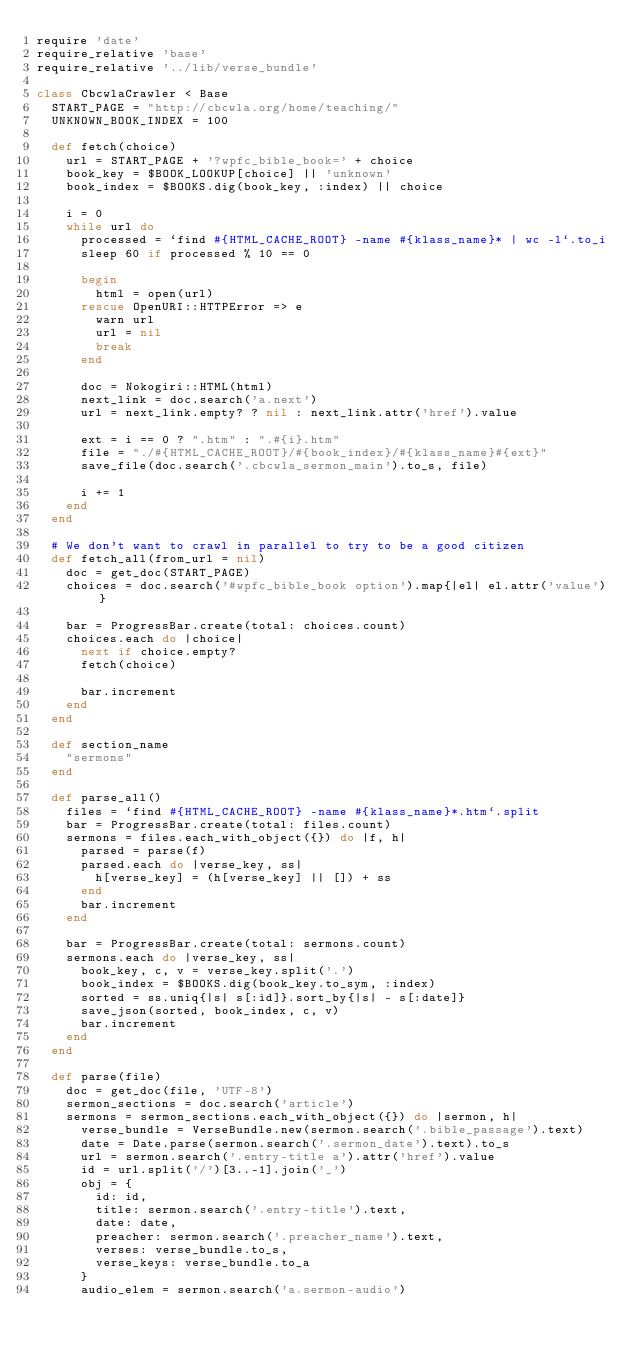Convert code to text. <code><loc_0><loc_0><loc_500><loc_500><_Ruby_>require 'date'
require_relative 'base'
require_relative '../lib/verse_bundle'

class CbcwlaCrawler < Base
  START_PAGE = "http://cbcwla.org/home/teaching/"
  UNKNOWN_BOOK_INDEX = 100

  def fetch(choice)
    url = START_PAGE + '?wpfc_bible_book=' + choice
    book_key = $BOOK_LOOKUP[choice] || 'unknown'
    book_index = $BOOKS.dig(book_key, :index) || choice

    i = 0
    while url do
      processed = `find #{HTML_CACHE_ROOT} -name #{klass_name}* | wc -l`.to_i
      sleep 60 if processed % 10 == 0

      begin
        html = open(url)
      rescue OpenURI::HTTPError => e
        warn url
        url = nil
        break
      end

      doc = Nokogiri::HTML(html)
      next_link = doc.search('a.next')
      url = next_link.empty? ? nil : next_link.attr('href').value

      ext = i == 0 ? ".htm" : ".#{i}.htm"
      file = "./#{HTML_CACHE_ROOT}/#{book_index}/#{klass_name}#{ext}"
      save_file(doc.search('.cbcwla_sermon_main').to_s, file)

      i += 1
    end
  end

  # We don't want to crawl in parallel to try to be a good citizen
  def fetch_all(from_url = nil)
    doc = get_doc(START_PAGE)
    choices = doc.search('#wpfc_bible_book option').map{|el| el.attr('value')}

    bar = ProgressBar.create(total: choices.count)
    choices.each do |choice|
      next if choice.empty?
      fetch(choice)

      bar.increment
    end
  end

  def section_name
    "sermons"
  end

  def parse_all()
    files = `find #{HTML_CACHE_ROOT} -name #{klass_name}*.htm`.split
    bar = ProgressBar.create(total: files.count)
    sermons = files.each_with_object({}) do |f, h|
      parsed = parse(f)
      parsed.each do |verse_key, ss|
        h[verse_key] = (h[verse_key] || []) + ss
      end
      bar.increment
    end

    bar = ProgressBar.create(total: sermons.count)
    sermons.each do |verse_key, ss|
      book_key, c, v = verse_key.split('.')
      book_index = $BOOKS.dig(book_key.to_sym, :index)
      sorted = ss.uniq{|s| s[:id]}.sort_by{|s| - s[:date]}
      save_json(sorted, book_index, c, v)
      bar.increment
    end
  end

  def parse(file)
    doc = get_doc(file, 'UTF-8')
    sermon_sections = doc.search('article')
    sermons = sermon_sections.each_with_object({}) do |sermon, h|
      verse_bundle = VerseBundle.new(sermon.search('.bible_passage').text)
      date = Date.parse(sermon.search('.sermon_date').text).to_s
      url = sermon.search('.entry-title a').attr('href').value
      id = url.split('/')[3..-1].join('_')
      obj = {
        id: id,
        title: sermon.search('.entry-title').text,
        date: date,
        preacher: sermon.search('.preacher_name').text,
        verses: verse_bundle.to_s,
        verse_keys: verse_bundle.to_a
      }
      audio_elem = sermon.search('a.sermon-audio')</code> 